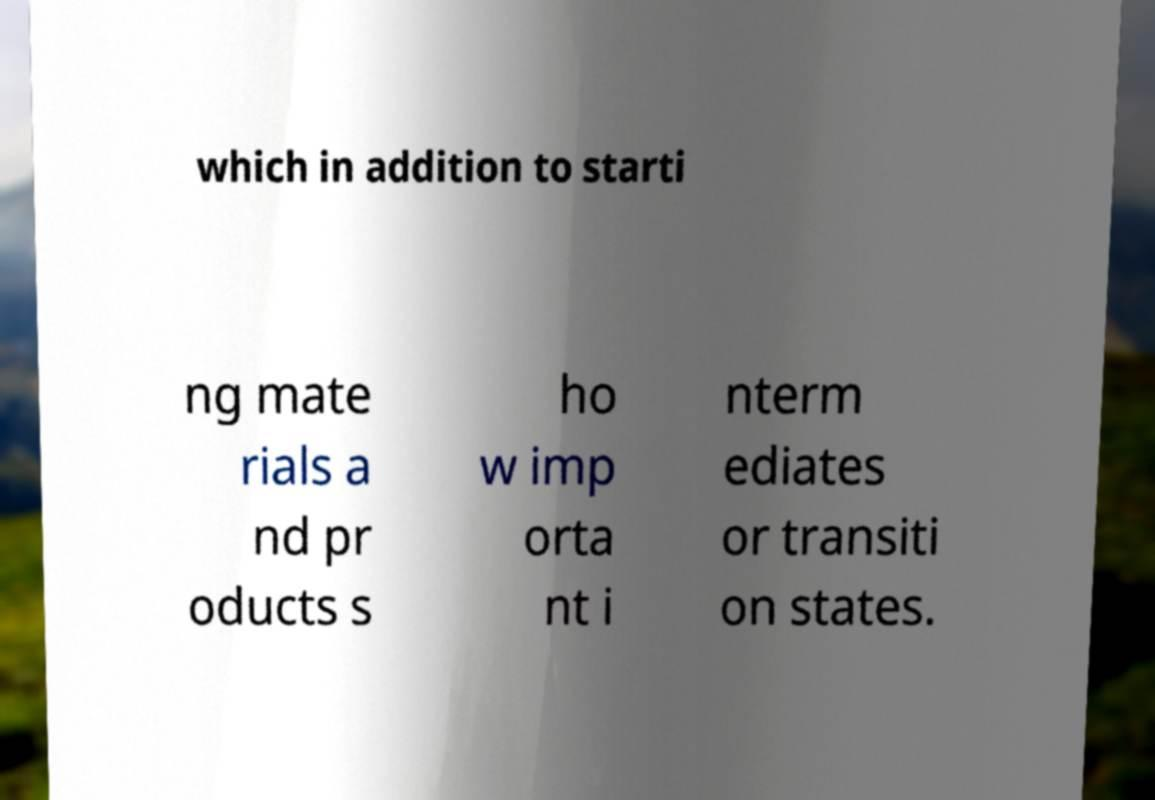Can you read and provide the text displayed in the image?This photo seems to have some interesting text. Can you extract and type it out for me? which in addition to starti ng mate rials a nd pr oducts s ho w imp orta nt i nterm ediates or transiti on states. 